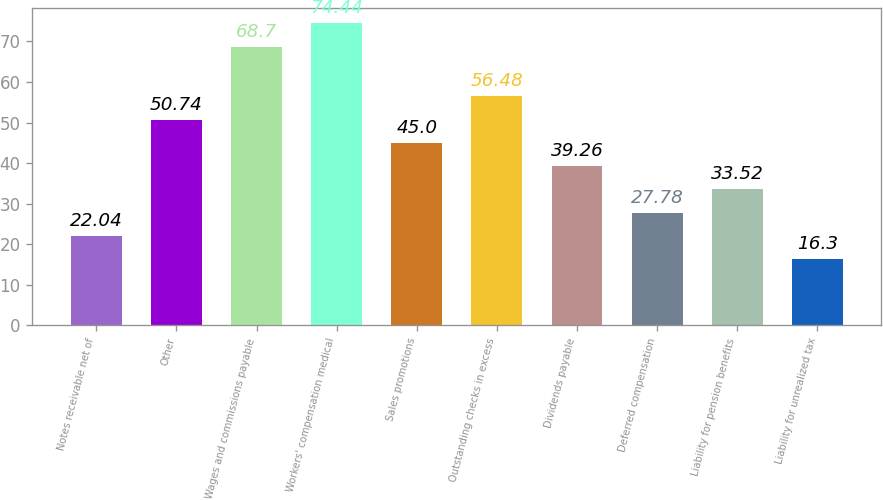Convert chart. <chart><loc_0><loc_0><loc_500><loc_500><bar_chart><fcel>Notes receivable net of<fcel>Other<fcel>Wages and commissions payable<fcel>Workers' compensation medical<fcel>Sales promotions<fcel>Outstanding checks in excess<fcel>Dividends payable<fcel>Deferred compensation<fcel>Liability for pension benefits<fcel>Liability for unrealized tax<nl><fcel>22.04<fcel>50.74<fcel>68.7<fcel>74.44<fcel>45<fcel>56.48<fcel>39.26<fcel>27.78<fcel>33.52<fcel>16.3<nl></chart> 